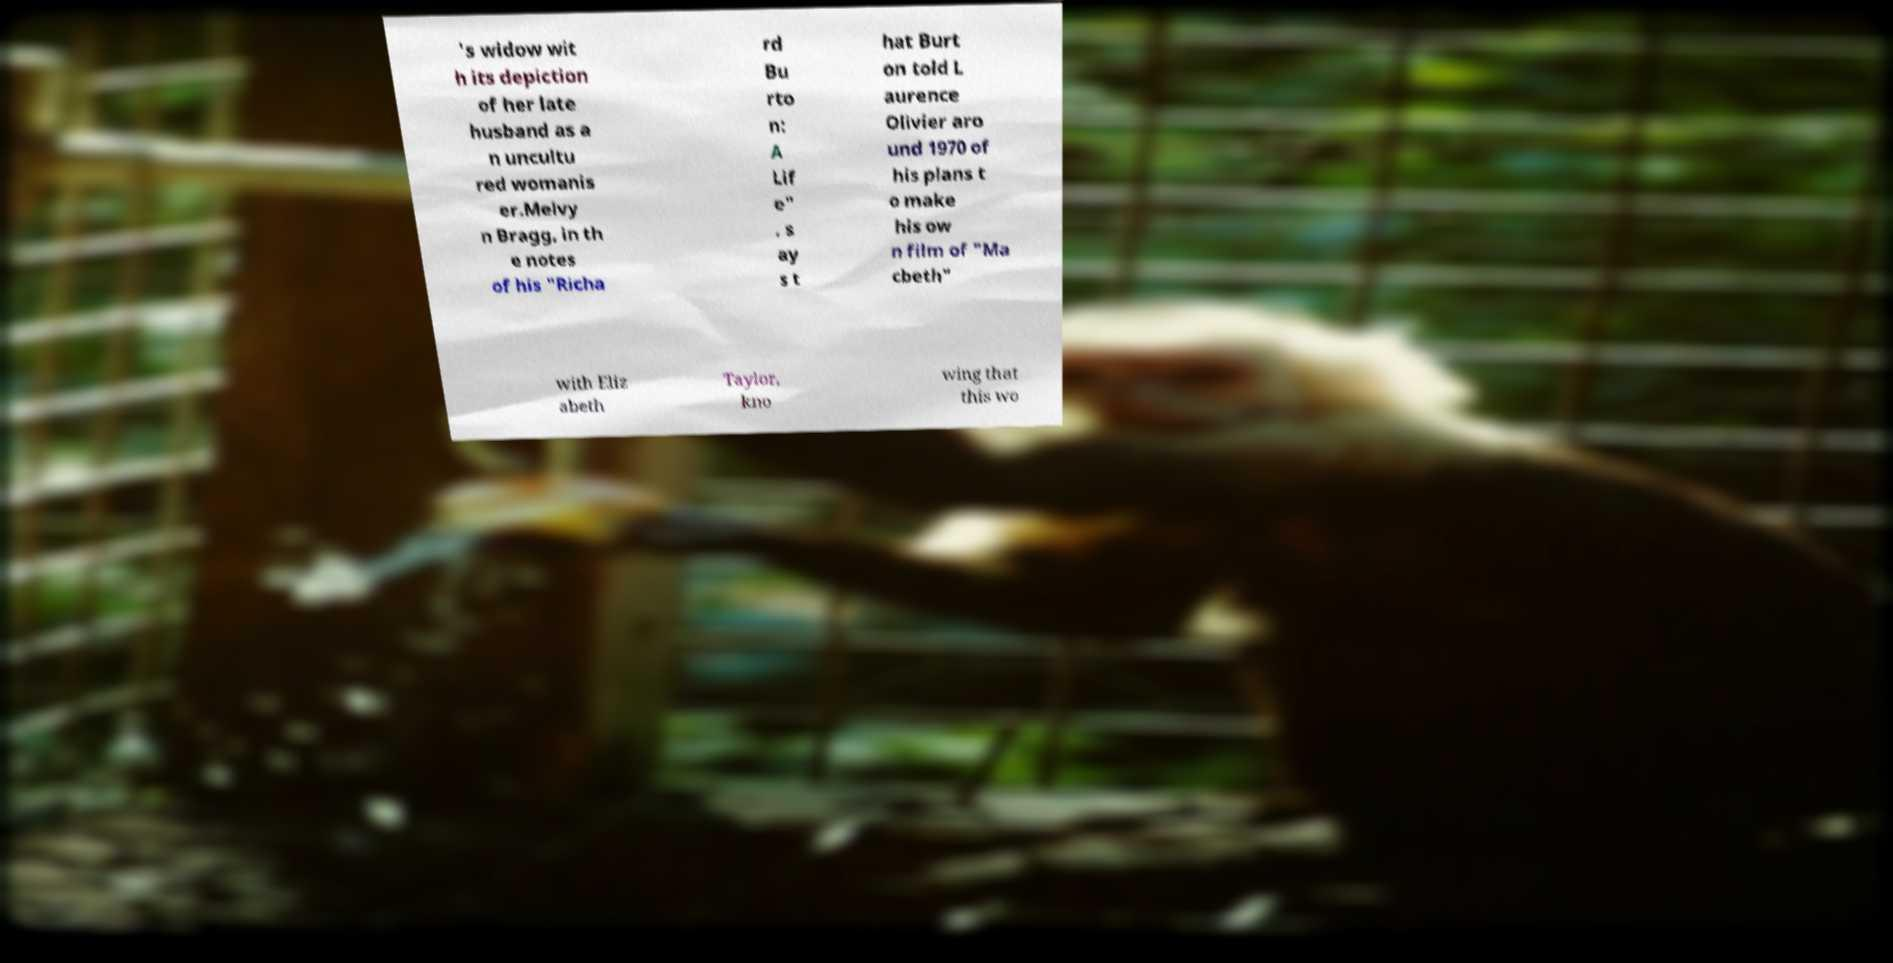Please identify and transcribe the text found in this image. 's widow wit h its depiction of her late husband as a n uncultu red womanis er.Melvy n Bragg, in th e notes of his "Richa rd Bu rto n: A Lif e" , s ay s t hat Burt on told L aurence Olivier aro und 1970 of his plans t o make his ow n film of "Ma cbeth" with Eliz abeth Taylor, kno wing that this wo 